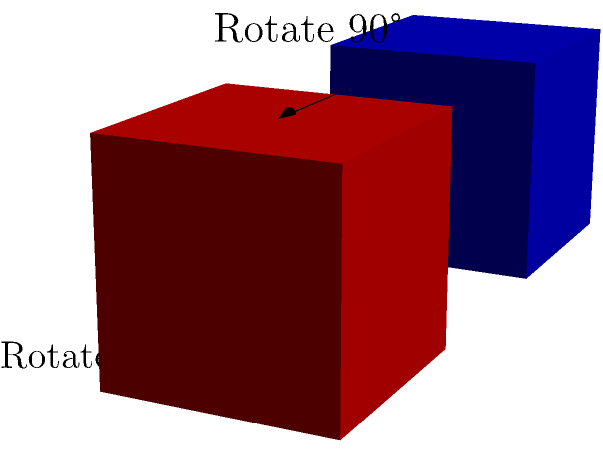A cube is rotated 90 degrees around one of its edges. How many different orientations can the cube have after this rotation? (Assume the cube starts in a fixed position) Let's approach this step-by-step:

1) First, we need to understand what we're counting. We're looking for unique orientations after a 90-degree rotation around any edge.

2) A cube has 12 edges in total.

3) However, rotating around opposite edges will result in the same orientation. For example, rotating around the top-front edge is the same as rotating around the bottom-back edge, just in the opposite direction.

4) This means we only need to consider 6 unique edges (half of the total edges).

5) Now, for each edge, a 90-degree rotation will result in a unique orientation.

6) Therefore, there are 6 possible orientations after a single 90-degree rotation around an edge.

7) We also need to consider the original orientation (before any rotation).

8) So, the total number of possible orientations is 6 (from rotations) + 1 (original) = 7.

This problem relates to group theory because the rotations of a cube form a group, where each rotation is an element of the group, and the operation is composition of rotations.
Answer: 7 orientations 